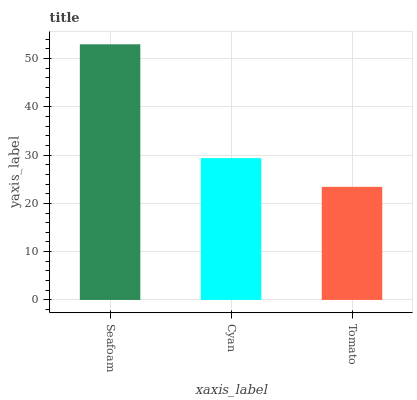Is Tomato the minimum?
Answer yes or no. Yes. Is Seafoam the maximum?
Answer yes or no. Yes. Is Cyan the minimum?
Answer yes or no. No. Is Cyan the maximum?
Answer yes or no. No. Is Seafoam greater than Cyan?
Answer yes or no. Yes. Is Cyan less than Seafoam?
Answer yes or no. Yes. Is Cyan greater than Seafoam?
Answer yes or no. No. Is Seafoam less than Cyan?
Answer yes or no. No. Is Cyan the high median?
Answer yes or no. Yes. Is Cyan the low median?
Answer yes or no. Yes. Is Tomato the high median?
Answer yes or no. No. Is Seafoam the low median?
Answer yes or no. No. 